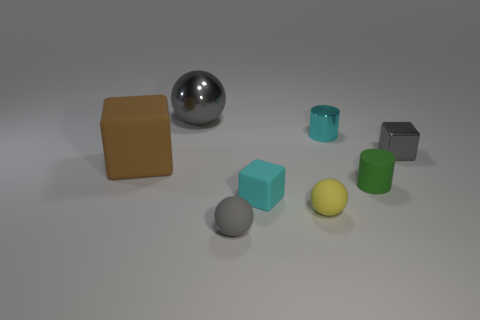Subtract all small metal blocks. How many blocks are left? 2 Subtract all cyan cylinders. How many cylinders are left? 1 Subtract all cubes. How many objects are left? 5 Subtract 2 blocks. How many blocks are left? 1 Subtract 0 brown spheres. How many objects are left? 8 Subtract all red cubes. Subtract all red cylinders. How many cubes are left? 3 Subtract all cyan balls. How many gray cylinders are left? 0 Subtract all large brown cylinders. Subtract all large gray metallic balls. How many objects are left? 7 Add 7 gray metallic balls. How many gray metallic balls are left? 8 Add 6 blocks. How many blocks exist? 9 